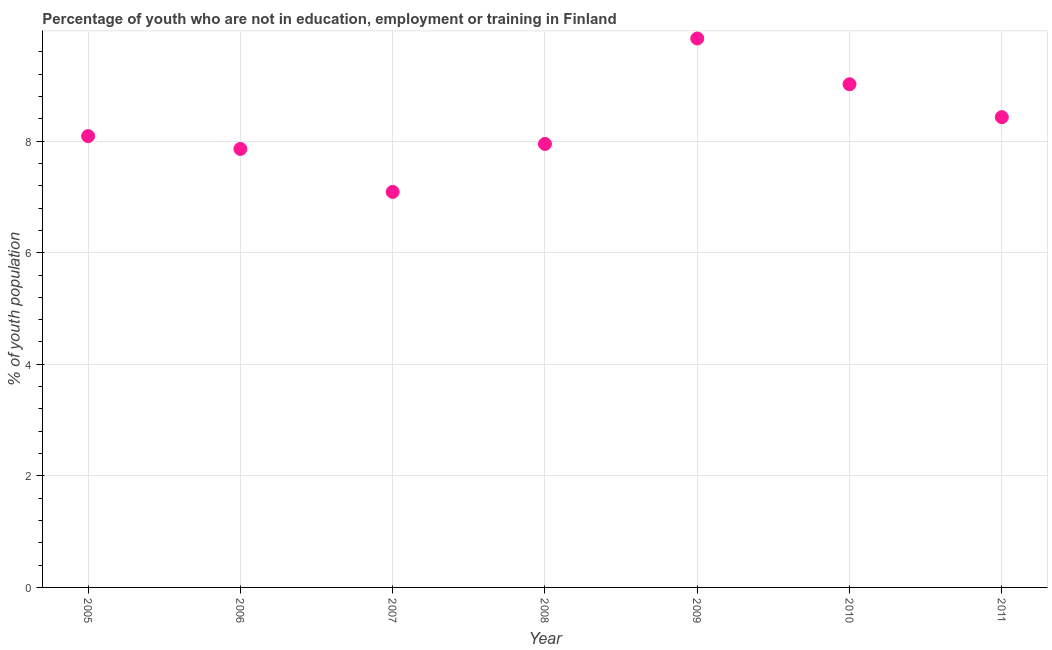What is the unemployed youth population in 2007?
Offer a very short reply. 7.09. Across all years, what is the maximum unemployed youth population?
Offer a terse response. 9.84. Across all years, what is the minimum unemployed youth population?
Give a very brief answer. 7.09. What is the sum of the unemployed youth population?
Offer a terse response. 58.28. What is the difference between the unemployed youth population in 2006 and 2011?
Provide a succinct answer. -0.57. What is the average unemployed youth population per year?
Keep it short and to the point. 8.33. What is the median unemployed youth population?
Give a very brief answer. 8.09. In how many years, is the unemployed youth population greater than 1.6 %?
Offer a very short reply. 7. What is the ratio of the unemployed youth population in 2006 to that in 2010?
Make the answer very short. 0.87. Is the unemployed youth population in 2008 less than that in 2011?
Make the answer very short. Yes. What is the difference between the highest and the second highest unemployed youth population?
Ensure brevity in your answer.  0.82. What is the difference between the highest and the lowest unemployed youth population?
Your answer should be compact. 2.75. Does the graph contain any zero values?
Provide a short and direct response. No. What is the title of the graph?
Provide a succinct answer. Percentage of youth who are not in education, employment or training in Finland. What is the label or title of the X-axis?
Ensure brevity in your answer.  Year. What is the label or title of the Y-axis?
Keep it short and to the point. % of youth population. What is the % of youth population in 2005?
Keep it short and to the point. 8.09. What is the % of youth population in 2006?
Keep it short and to the point. 7.86. What is the % of youth population in 2007?
Offer a very short reply. 7.09. What is the % of youth population in 2008?
Your answer should be compact. 7.95. What is the % of youth population in 2009?
Your response must be concise. 9.84. What is the % of youth population in 2010?
Give a very brief answer. 9.02. What is the % of youth population in 2011?
Give a very brief answer. 8.43. What is the difference between the % of youth population in 2005 and 2006?
Keep it short and to the point. 0.23. What is the difference between the % of youth population in 2005 and 2007?
Provide a succinct answer. 1. What is the difference between the % of youth population in 2005 and 2008?
Keep it short and to the point. 0.14. What is the difference between the % of youth population in 2005 and 2009?
Provide a succinct answer. -1.75. What is the difference between the % of youth population in 2005 and 2010?
Offer a very short reply. -0.93. What is the difference between the % of youth population in 2005 and 2011?
Provide a short and direct response. -0.34. What is the difference between the % of youth population in 2006 and 2007?
Provide a short and direct response. 0.77. What is the difference between the % of youth population in 2006 and 2008?
Ensure brevity in your answer.  -0.09. What is the difference between the % of youth population in 2006 and 2009?
Provide a succinct answer. -1.98. What is the difference between the % of youth population in 2006 and 2010?
Ensure brevity in your answer.  -1.16. What is the difference between the % of youth population in 2006 and 2011?
Offer a very short reply. -0.57. What is the difference between the % of youth population in 2007 and 2008?
Keep it short and to the point. -0.86. What is the difference between the % of youth population in 2007 and 2009?
Provide a short and direct response. -2.75. What is the difference between the % of youth population in 2007 and 2010?
Your answer should be very brief. -1.93. What is the difference between the % of youth population in 2007 and 2011?
Provide a succinct answer. -1.34. What is the difference between the % of youth population in 2008 and 2009?
Offer a very short reply. -1.89. What is the difference between the % of youth population in 2008 and 2010?
Offer a very short reply. -1.07. What is the difference between the % of youth population in 2008 and 2011?
Your answer should be compact. -0.48. What is the difference between the % of youth population in 2009 and 2010?
Offer a very short reply. 0.82. What is the difference between the % of youth population in 2009 and 2011?
Make the answer very short. 1.41. What is the difference between the % of youth population in 2010 and 2011?
Keep it short and to the point. 0.59. What is the ratio of the % of youth population in 2005 to that in 2006?
Your answer should be very brief. 1.03. What is the ratio of the % of youth population in 2005 to that in 2007?
Provide a succinct answer. 1.14. What is the ratio of the % of youth population in 2005 to that in 2009?
Keep it short and to the point. 0.82. What is the ratio of the % of youth population in 2005 to that in 2010?
Ensure brevity in your answer.  0.9. What is the ratio of the % of youth population in 2006 to that in 2007?
Ensure brevity in your answer.  1.11. What is the ratio of the % of youth population in 2006 to that in 2009?
Offer a very short reply. 0.8. What is the ratio of the % of youth population in 2006 to that in 2010?
Offer a very short reply. 0.87. What is the ratio of the % of youth population in 2006 to that in 2011?
Provide a short and direct response. 0.93. What is the ratio of the % of youth population in 2007 to that in 2008?
Give a very brief answer. 0.89. What is the ratio of the % of youth population in 2007 to that in 2009?
Make the answer very short. 0.72. What is the ratio of the % of youth population in 2007 to that in 2010?
Your answer should be very brief. 0.79. What is the ratio of the % of youth population in 2007 to that in 2011?
Ensure brevity in your answer.  0.84. What is the ratio of the % of youth population in 2008 to that in 2009?
Provide a succinct answer. 0.81. What is the ratio of the % of youth population in 2008 to that in 2010?
Provide a succinct answer. 0.88. What is the ratio of the % of youth population in 2008 to that in 2011?
Provide a succinct answer. 0.94. What is the ratio of the % of youth population in 2009 to that in 2010?
Your response must be concise. 1.09. What is the ratio of the % of youth population in 2009 to that in 2011?
Make the answer very short. 1.17. What is the ratio of the % of youth population in 2010 to that in 2011?
Your answer should be compact. 1.07. 